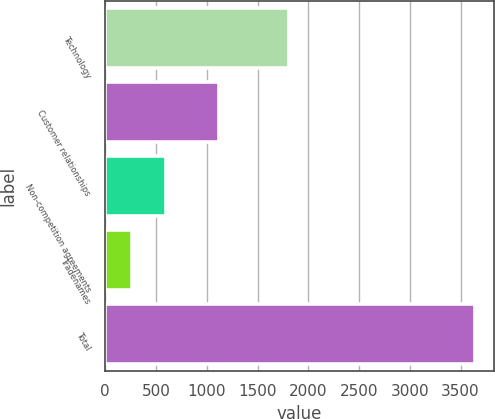Convert chart. <chart><loc_0><loc_0><loc_500><loc_500><bar_chart><fcel>Technology<fcel>Customer relationships<fcel>Non-competition agreements<fcel>Tradenames<fcel>Total<nl><fcel>1807<fcel>1119<fcel>597.5<fcel>259<fcel>3644<nl></chart> 